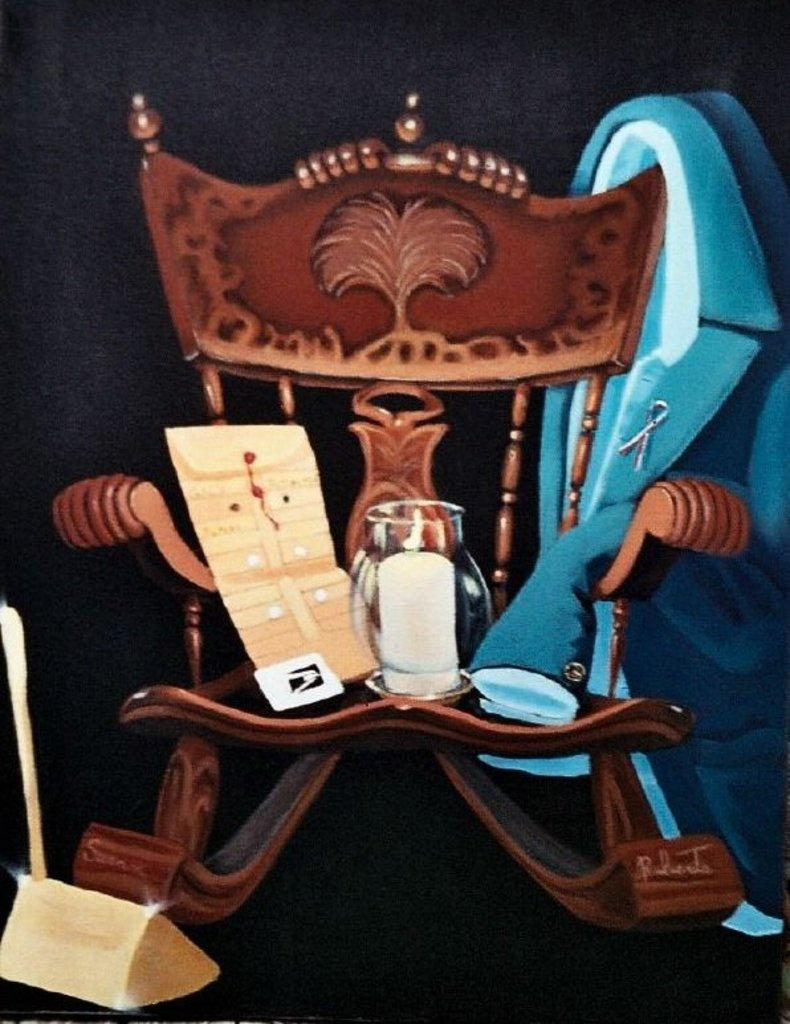What type of furniture is present in the image? There is a chair in the image. What items are placed on the chair? There is a bottle, a book, and a coat on the chair. Can you describe the object on the left side of the image? Unfortunately, the facts provided do not give any information about the object on the left side of the image. How many bees are buzzing around the cap in the image? There is no cap or bees present in the image. What color is the balloon tied to the coat in the image? There is no balloon present in the image. 